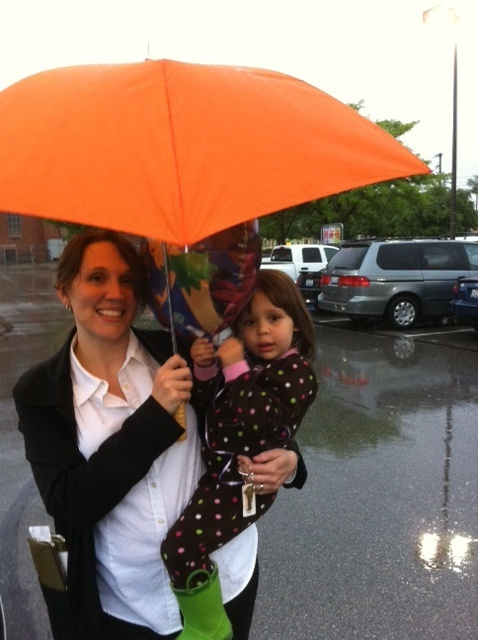Describe the objects in this image and their specific colors. I can see people in ivory, black, lavender, and darkgray tones, umbrella in ivory, salmon, and maroon tones, people in ivory, black, maroon, and darkgreen tones, car in ivory, black, gray, and darkgray tones, and truck in ivory, white, black, gray, and darkgray tones in this image. 